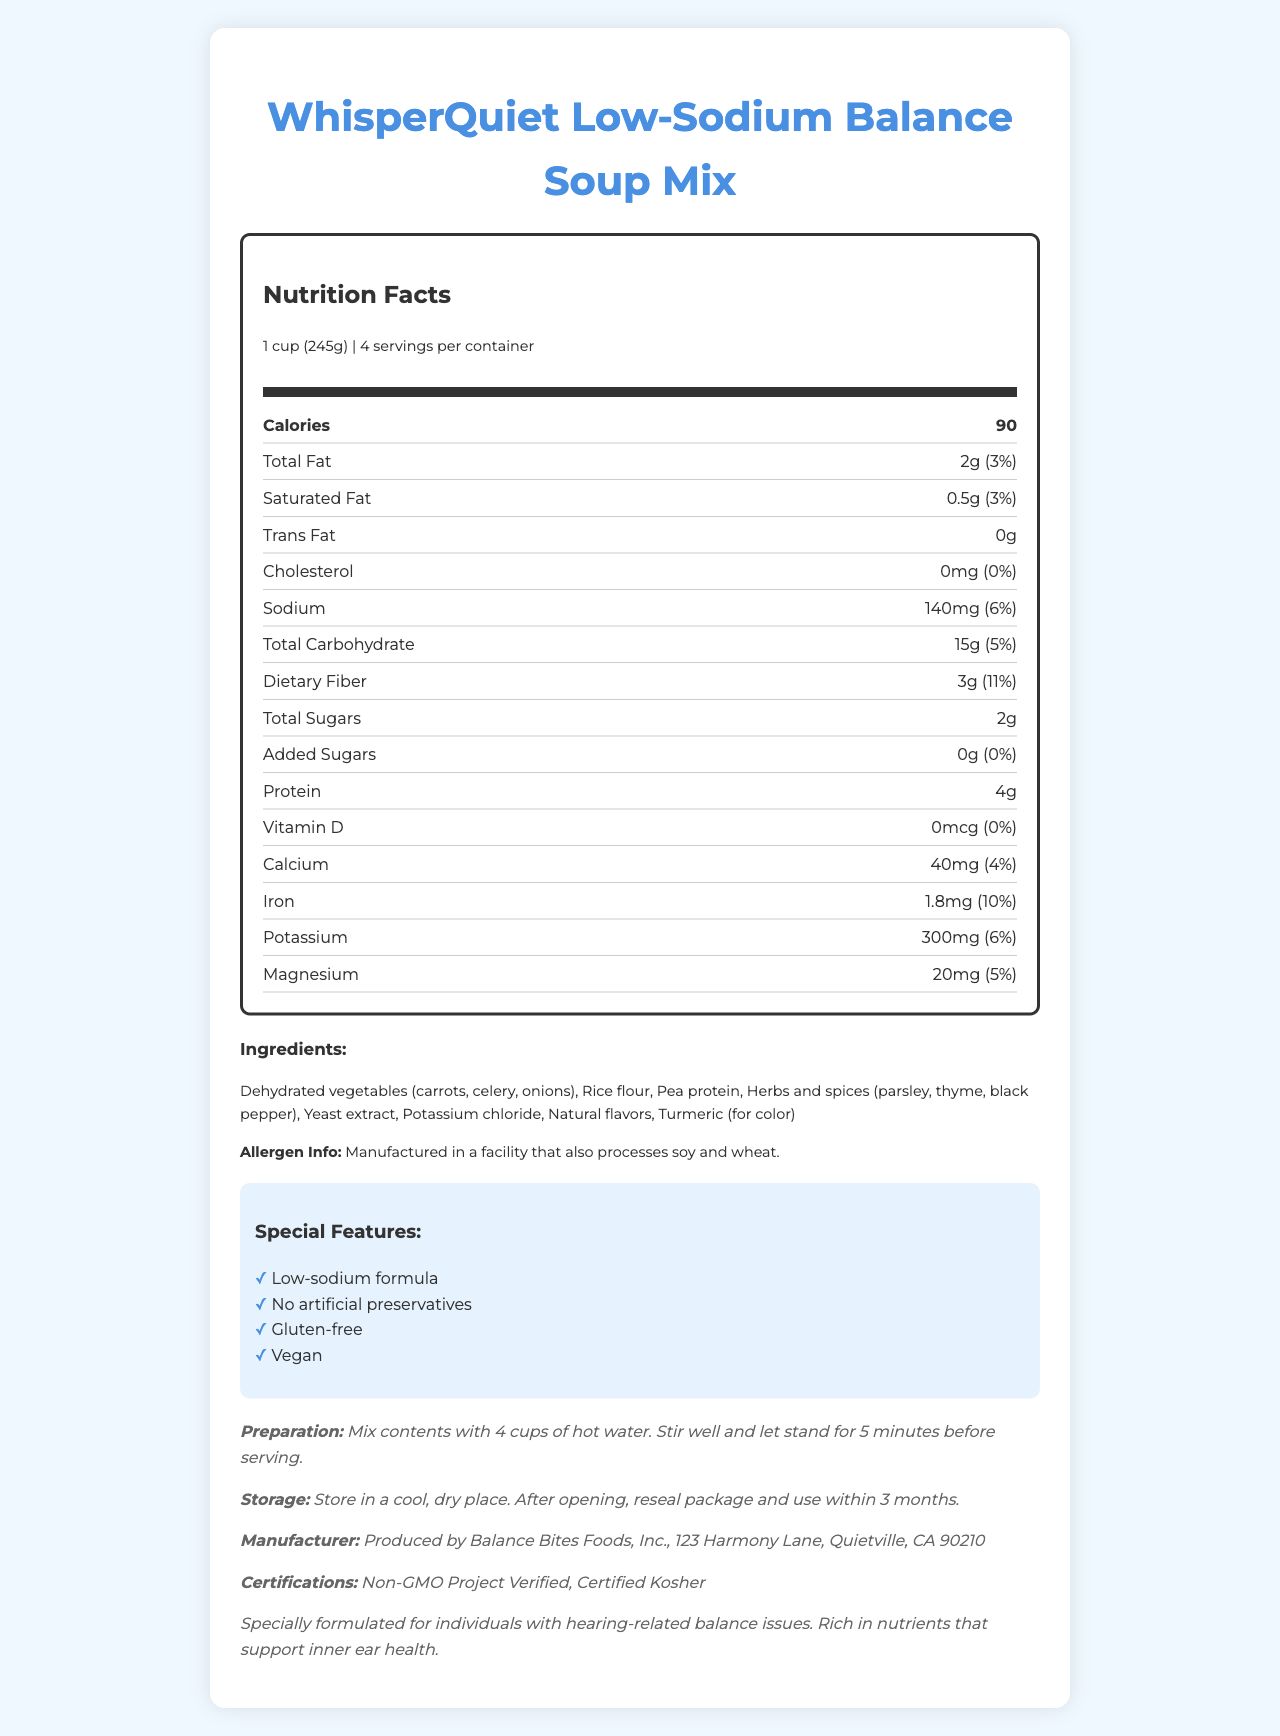What is the serving size of the WhisperQuiet Low-Sodium Balance Soup Mix? The serving size is listed as "1 cup (245g)" in the serving information on the document.
Answer: 1 cup (245g) How many servings are there per container of this soup mix? The document specifies that there are 4 servings per container.
Answer: 4 What is the total amount of dietary fiber per serving? Under "Dietary Fiber," it is mentioned that the amount is 3g per serving.
Answer: 3g What is the amount of sodium per serving? The sodium content per serving is listed as 140mg.
Answer: 140mg What are the main ingredients in the soup mix? The main ingredients are listed in the Ingredients section of the document.
Answer: Dehydrated vegetables (carrots, celery, onions), rice flour, pea protein, herbs and spices (parsley, thyme, black pepper), yeast extract, potassium chloride, natural flavors, turmeric (for color) Which of the following certifications does the soup mix have? A. USDA Organic B. Non-GMO Project Verified C. Fair Trade Certified D. Halal The document lists "Non-GMO Project Verified" as one of the certifications without mentioning the other options.
Answer: B. Non-GMO Project Verified What is the daily value percentage of calcium per serving? A. 2% B. 4% C. 6% D. 8% The daily value percentage for calcium per serving is listed as 4%.
Answer: B. 4% Is this soup mix gluten-free? The special features section lists "Gluten-free" as one of the attributes of the soup mix.
Answer: Yes Is there any trans fat in this soup mix? The document states that the trans fat amount is 0g per serving.
Answer: No Summarize the main features of the WhisperQuiet Low-Sodium Balance Soup Mix. The summary covers the product's main features, nutritional aspects, and special considerations, highlighting its design for individuals with hearing-related balance issues and its special certifications.
Answer: The WhisperQuiet Low-Sodium Balance Soup Mix is a nutritious vegan soup mix designed for people with hearing-related balance issues. It is low in sodium, gluten-free, non-GMO, and contains no artificial preservatives. It includes dehydrated vegetables, rice flour, and pea protein among other ingredients. Each serving has 90 calories, and it provides dietary fiber, protein, and essential minerals like calcium, iron, potassium, and magnesium. The soup mix is manufactured in a facility that processes soy and wheat and has certifications such as Non-GMO Project Verified and Certified Kosher. What is the exact manufacture date of this soup mix package? The document does not provide information regarding the manufacture date of the soup mix package.
Answer: Cannot be determined 